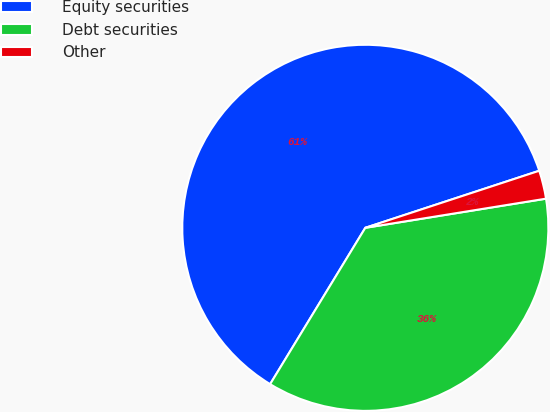<chart> <loc_0><loc_0><loc_500><loc_500><pie_chart><fcel>Equity securities<fcel>Debt securities<fcel>Other<nl><fcel>61.25%<fcel>36.25%<fcel>2.5%<nl></chart> 